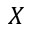<formula> <loc_0><loc_0><loc_500><loc_500>X</formula> 